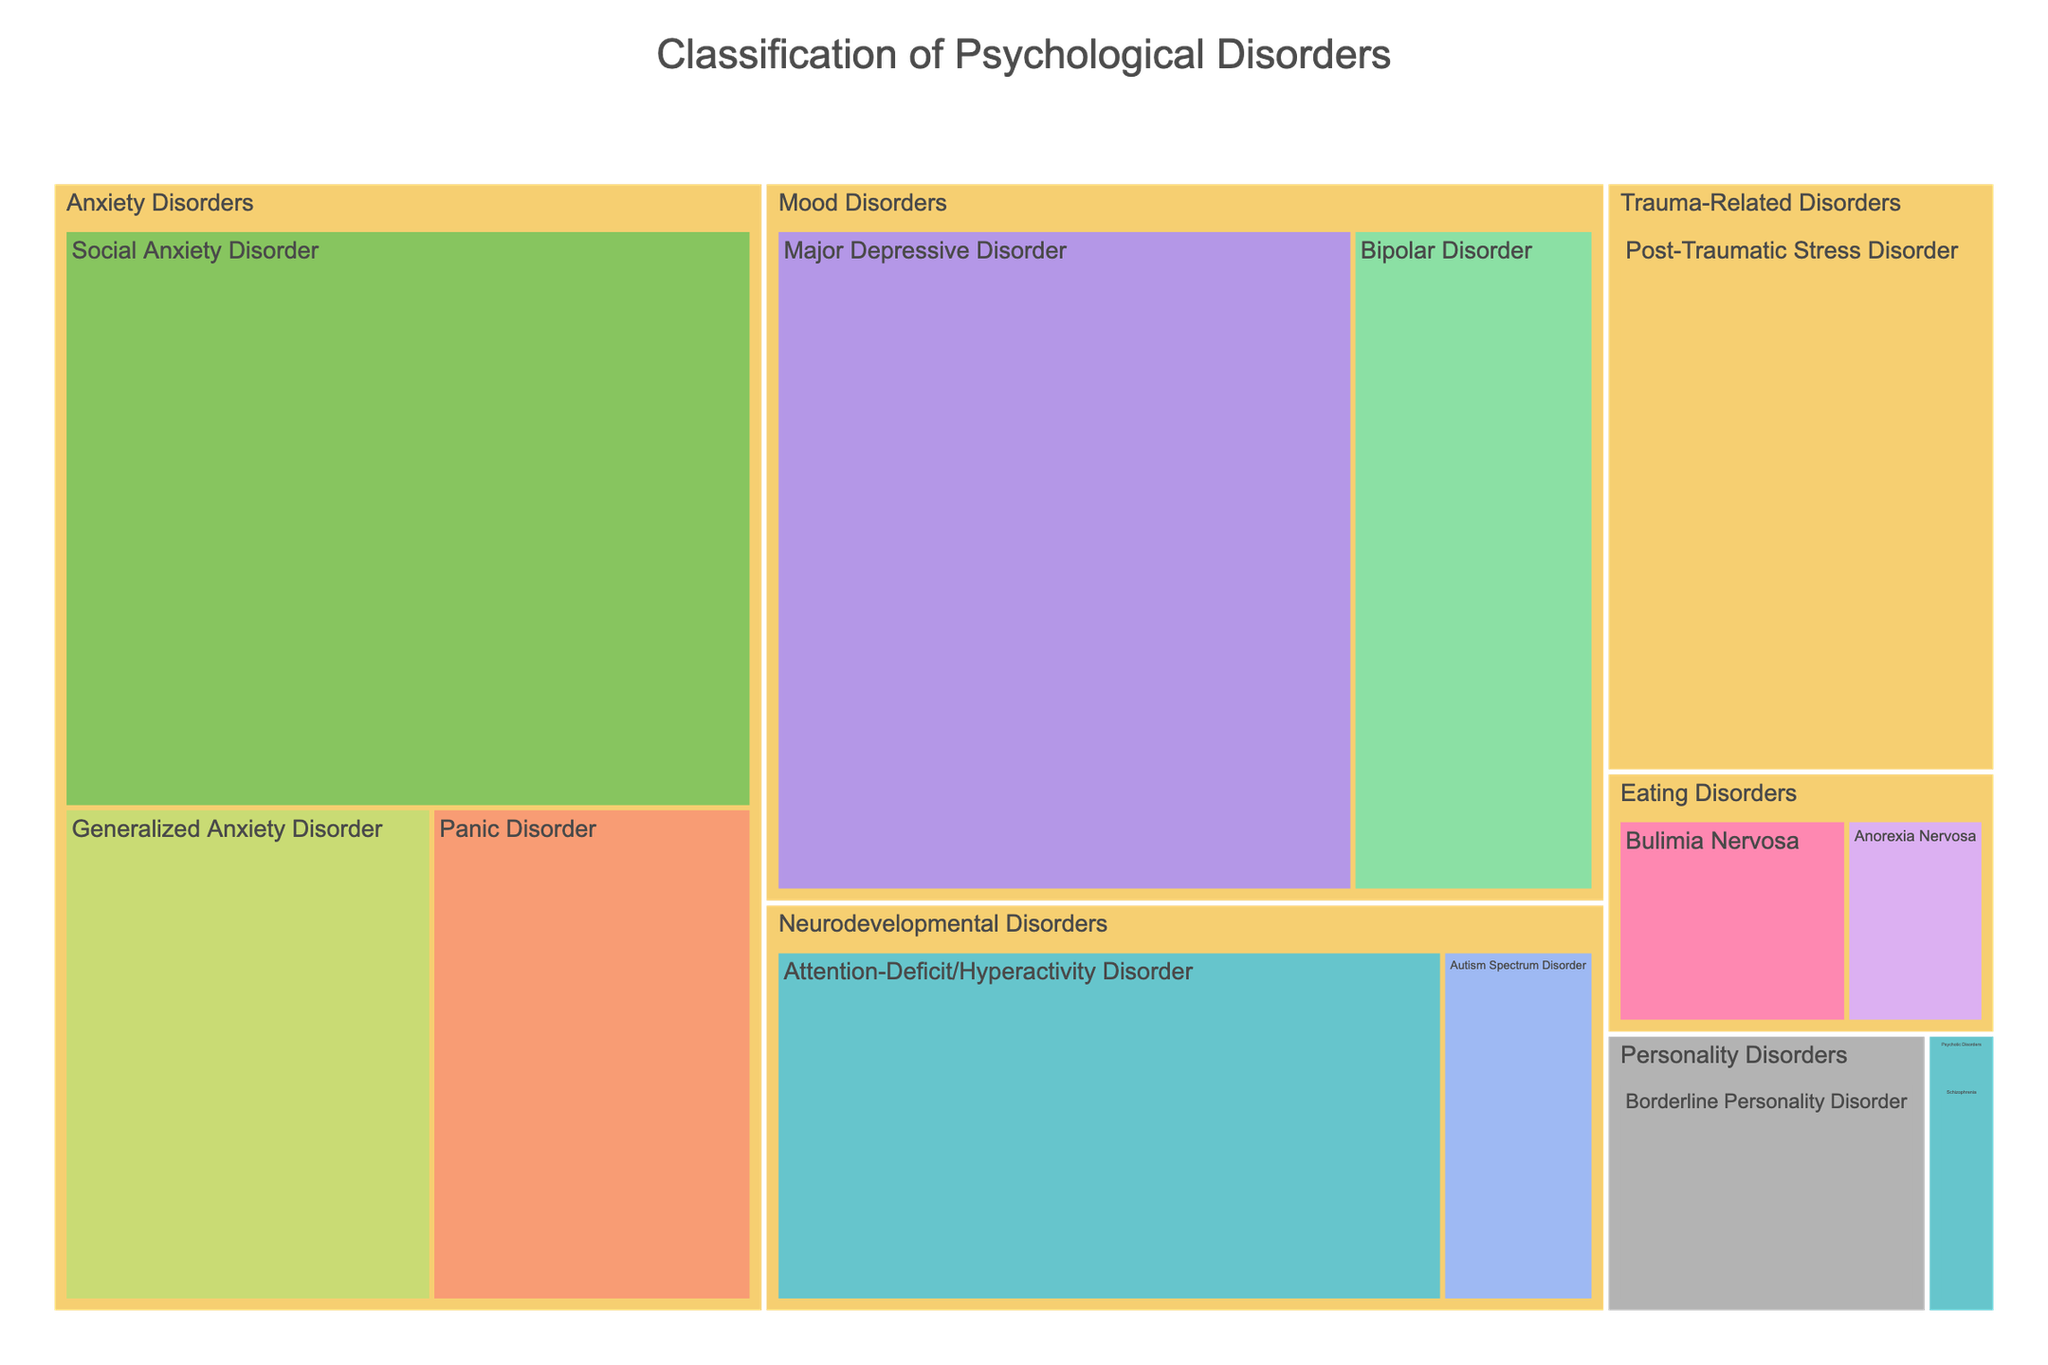what is the title of the treemap? The title of a treemap can typically be found at the top of the figure. By looking at the top section, we can see the title provided.
Answer: Classification of Psychological Disorders Which disorder has the highest prevalence? Identify the disorder with the largest area in the treemap since larger areas typically indicate higher values. From the data visualized, we can see that Social Anxiety Disorder has the largest box.
Answer: Social Anxiety Disorder Which treatment is associated with Panic Disorder? By identifying the box labeled "Panic Disorder" and checking the color-coded treatment associated with it, we can see that it is "Mindfulness-Based Stress Reduction."
Answer: Mindfulness-Based Stress Reduction What is the total prevalence of all Mood Disorders combined? Add the prevalence values of all disorders within the Mood Disorders category: 6.7% for Major Depressive Disorder and 2.8% for Bipolar Disorder. Hence, 6.7 + 2.8 = 9.5.
Answer: 9.5% Is the prevalence of Generalized Anxiety Disorder greater than that of Bipolar Disorder? Compare the box sizes or directly compare the prevalence values from the data: Generalized Anxiety Disorder has a prevalence of 3.1%, and Bipolar Disorder has 2.8%. 3.1 is greater than 2.8.
Answer: Yes Which disorder is treated using Dialectical Behavior Therapy? Find the box colored with the treatment "Dialectical Behavior Therapy," then check the label associated with this color. It's Borderline Personality Disorder.
Answer: Borderline Personality Disorder How does the prevalence of Schizophrenia compare to Anorexia Nervosa? Compare the prevalence values given: Schizophrenia has 0.3%, and Anorexia Nervosa has 0.6%. Schizophrenia has a lower prevalence.
Answer: Schizophrenia has a lower prevalence than Anorexia Nervosa What is the combined prevalence of disorders treated using cognitive or behavioral therapies? Sum the prevalence of the disorders treated with Cognitive Behavioral Therapy, Exposure Therapy, Family-Based Treatment, Behavioral Interventions, and Dialectical Behavior Therapy. Thus: 6.7% (Major Depressive Disorder) + 3.1% (Generalized Anxiety Disorder) + 0.6% (Anorexia Nervosa) + 4.4% (ADHD) + 1.4% (Borderline Personality Disorder) = 16.2%.
Answer: 16.2% What is the treatment for Post-Traumatic Stress Disorder? Locate the box for Post-Traumatic Stress Disorder and identify its associated treatment based on the color. The treatment is "Eye Movement Desensitization and Reprocessing."
Answer: Eye Movement Desensitization and Reprocessing 